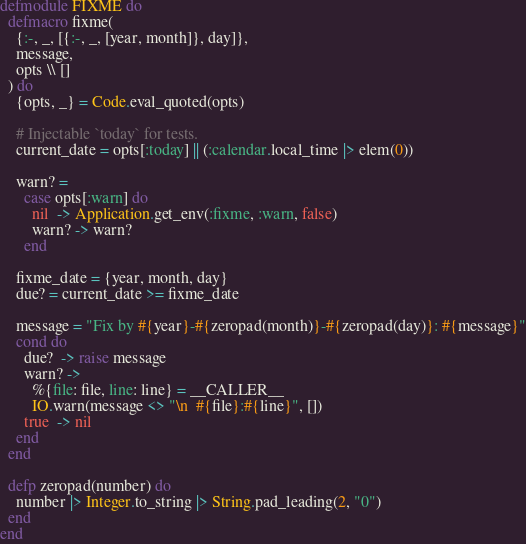<code> <loc_0><loc_0><loc_500><loc_500><_Elixir_>defmodule FIXME do
  defmacro fixme(
    {:-, _, [{:-, _, [year, month]}, day]},
    message,
    opts \\ []
  ) do
    {opts, _} = Code.eval_quoted(opts)

    # Injectable `today` for tests.
    current_date = opts[:today] || (:calendar.local_time |> elem(0))

    warn? =
      case opts[:warn] do
        nil  -> Application.get_env(:fixme, :warn, false)
        warn? -> warn?
      end

    fixme_date = {year, month, day}
    due? = current_date >= fixme_date

    message = "Fix by #{year}-#{zeropad(month)}-#{zeropad(day)}: #{message}"
    cond do
      due?  -> raise message
      warn? ->
        %{file: file, line: line} = __CALLER__
        IO.warn(message <> "\n  #{file}:#{line}", [])
      true  -> nil
    end
  end

  defp zeropad(number) do
    number |> Integer.to_string |> String.pad_leading(2, "0")
  end
end
</code> 